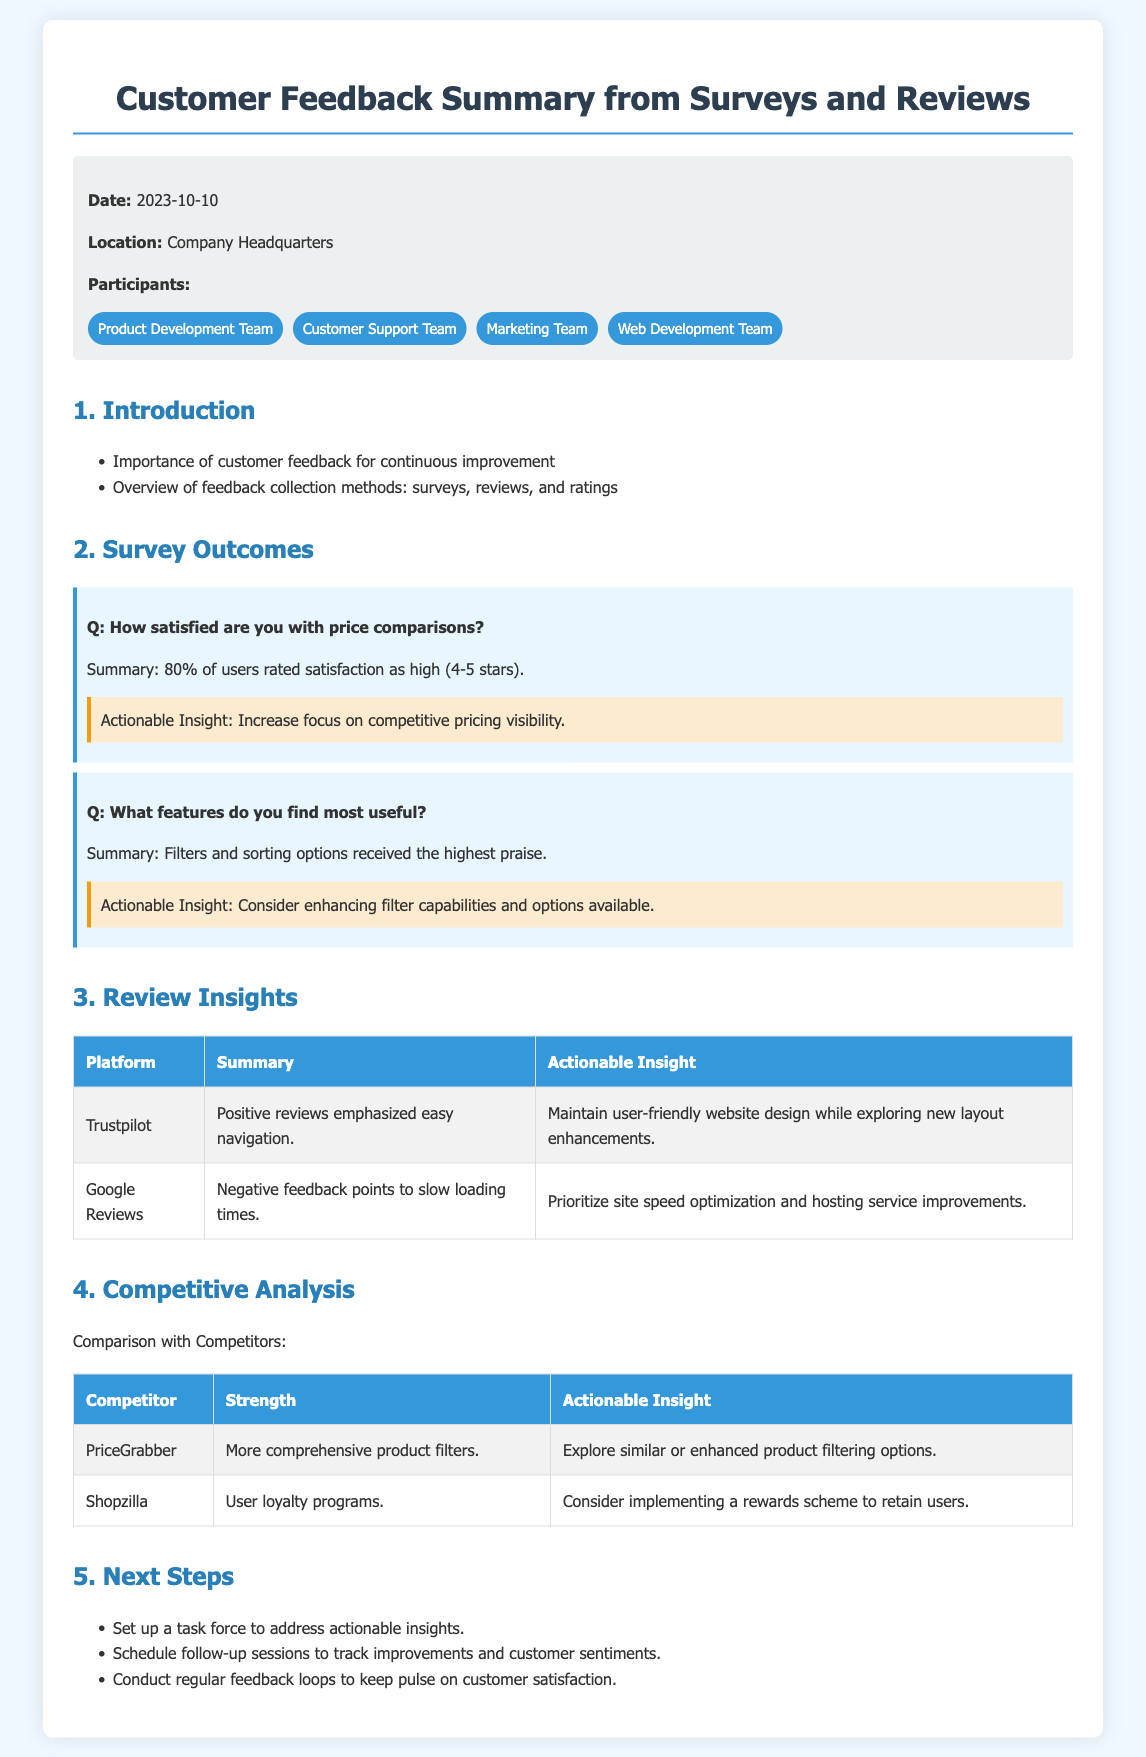What is the date of the feedback summary? The date of the feedback summary is mentioned in the meta-info section of the document.
Answer: 2023-10-10 Which team emphasized easy navigation in reviews? The team referenced in positive reviews about easy navigation is mentioned in the Review Insights section.
Answer: Trustpilot What percentage of users rated satisfaction with price comparisons as high? The percentage of users who rated satisfaction as high can be found in the Survey Outcomes section.
Answer: 80% What feature received the highest praise from users? The feature that received the highest praise is identified in the Survey Outcomes section under user feedback.
Answer: Filters and sorting options What actionable insight is related to slow loading times? The actionable insight regarding slow loading times is discussed in the Review Insights section of the document.
Answer: Prioritize site speed optimization and hosting service improvements What is a strength of PriceGrabber compared to our website? The strength of PriceGrabber is compared to our website in the Competitive Analysis section, highlighting its features.
Answer: More comprehensive product filters What is one of the next steps proposed in the feedback summary? One of the next steps proposed is outlined in the "Next Steps" section of the document.
Answer: Set up a task force to address actionable insights How many participant teams are involved in this feedback summary? The number of participant teams is specified in the meta-info of the document.
Answer: Four 